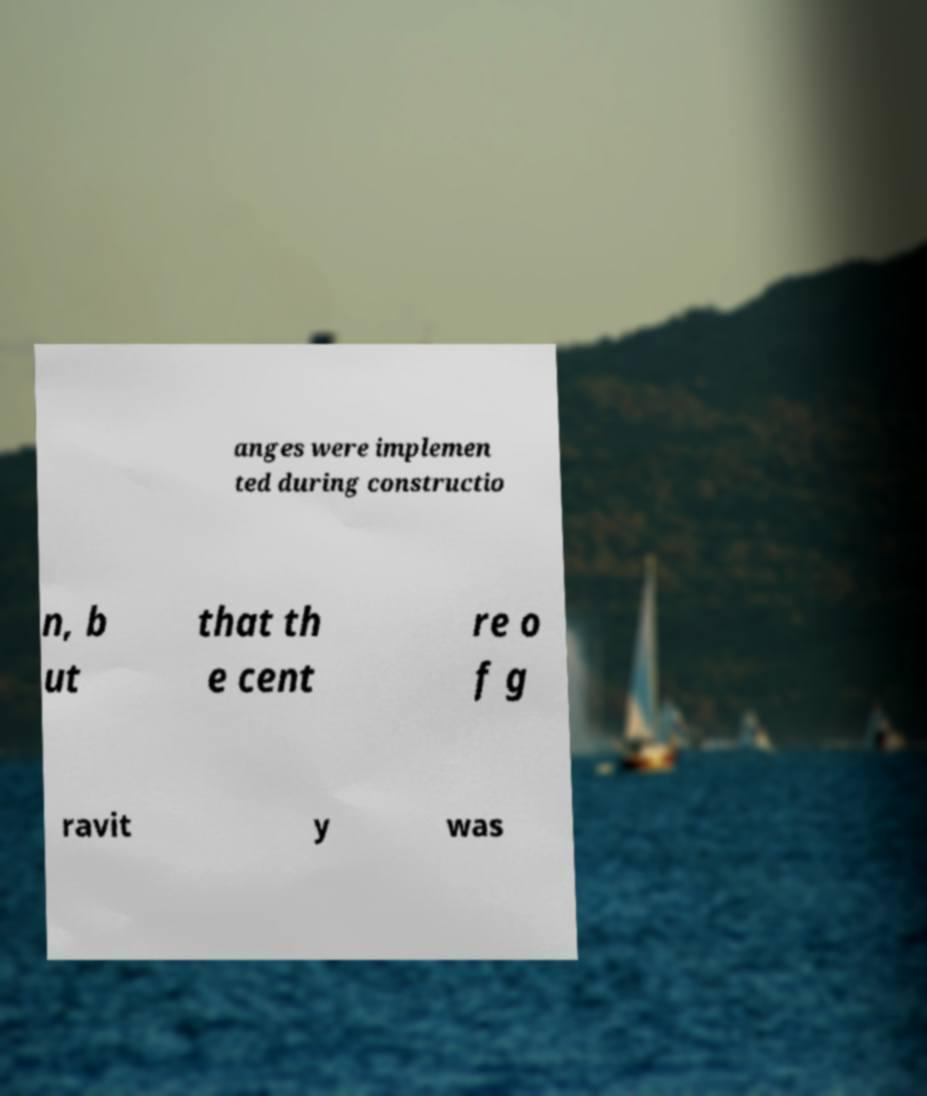Can you accurately transcribe the text from the provided image for me? anges were implemen ted during constructio n, b ut that th e cent re o f g ravit y was 